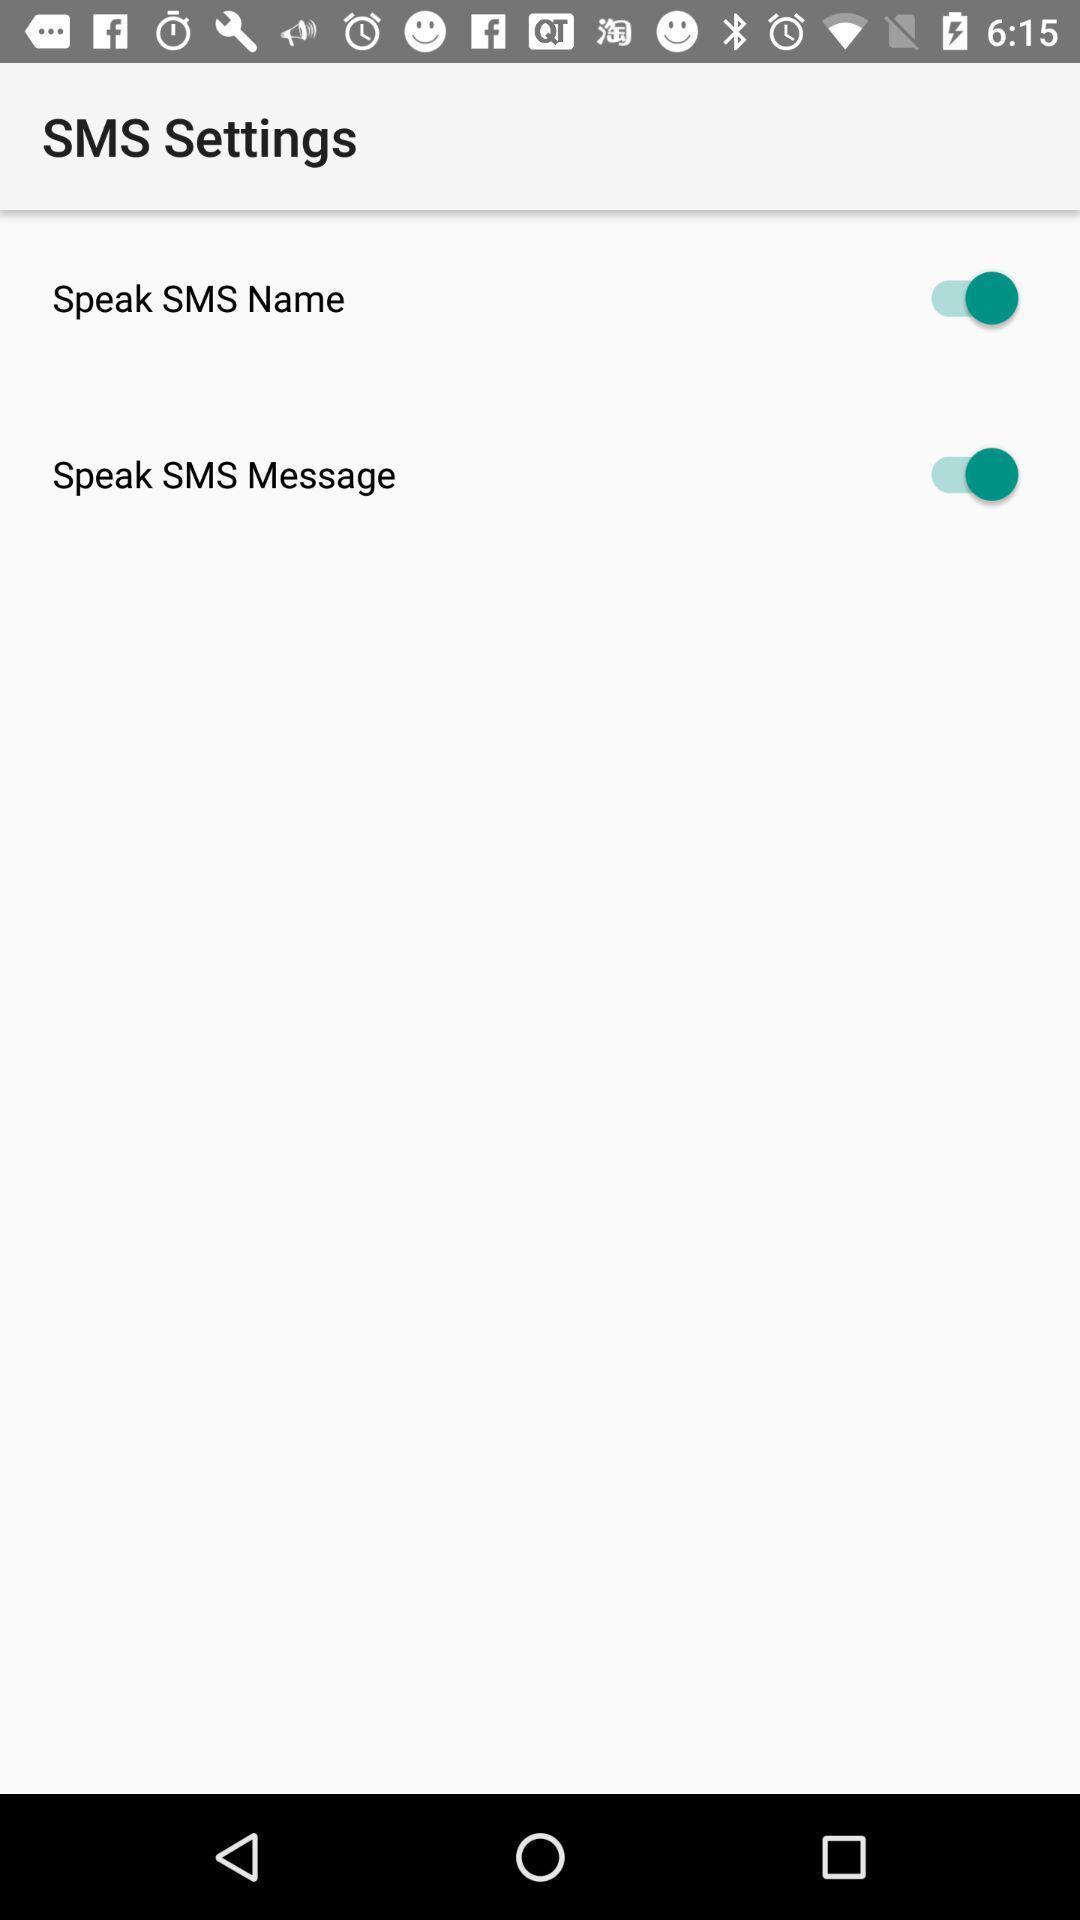Provide a description of this screenshot. Sms settings page displaying in android application. 